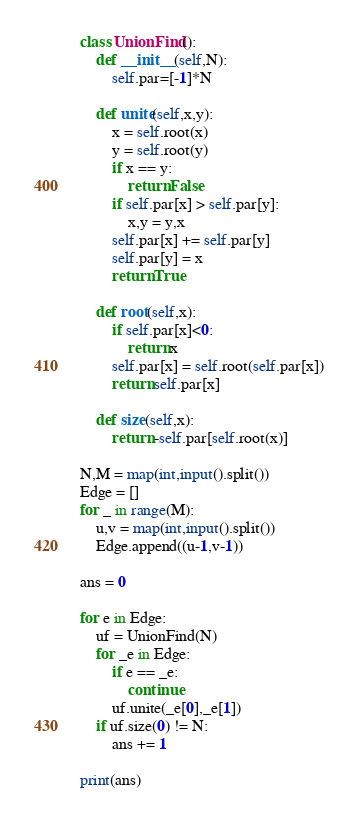<code> <loc_0><loc_0><loc_500><loc_500><_Python_>class UnionFind():
    def __init__(self,N):
        self.par=[-1]*N
    
    def unite(self,x,y):
        x = self.root(x)
        y = self.root(y)
        if x == y:
            return False
        if self.par[x] > self.par[y]:
            x,y = y,x
        self.par[x] += self.par[y]
        self.par[y] = x
        return True
    
    def root(self,x):
        if self.par[x]<0:
            return x
        self.par[x] = self.root(self.par[x])
        return self.par[x]
    
    def size(self,x):
        return -self.par[self.root(x)]

N,M = map(int,input().split())
Edge = []
for _ in range(M):
    u,v = map(int,input().split())
    Edge.append((u-1,v-1))

ans = 0

for e in Edge:
    uf = UnionFind(N)
    for _e in Edge:
        if e == _e:
            continue
        uf.unite(_e[0],_e[1])
    if uf.size(0) != N:
        ans += 1

print(ans)</code> 